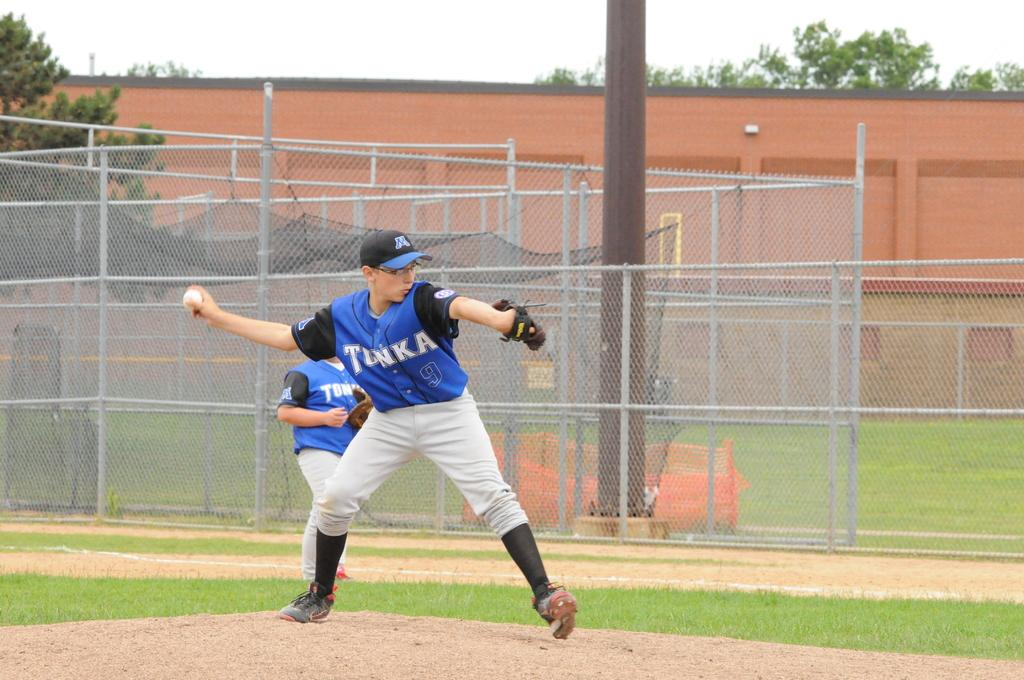Provide a one-sentence caption for the provided image. Baseball player wearing a jersey saying TONKA about to pitch. 